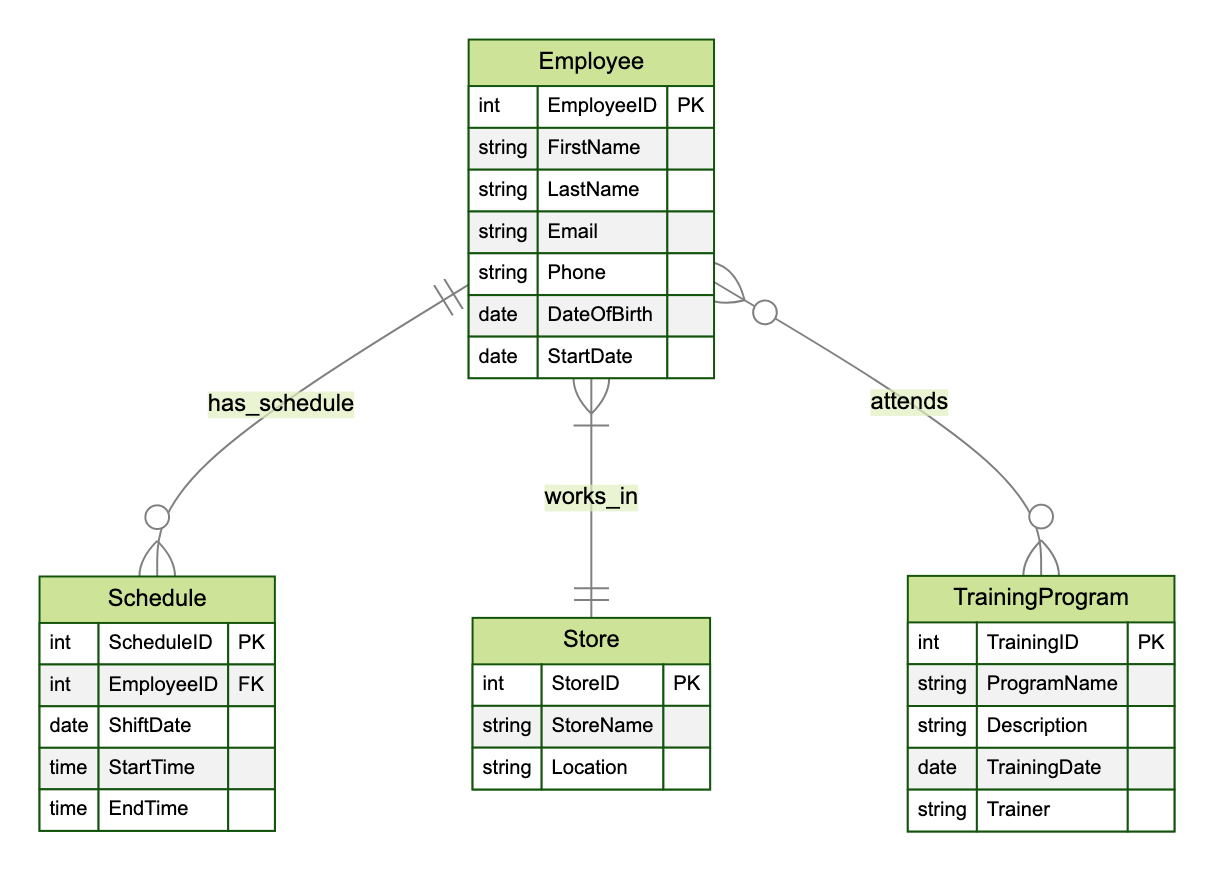What is the primary key of the Employee entity? The primary key of the Employee entity is EmployeeID, which uniquely identifies each employee in the diagram.
Answer: EmployeeID How many attributes does the Store entity have? The Store entity has three attributes: StoreID, StoreName, and Location. This count comes from looking at the attributes listed under the Store entity in the diagram.
Answer: 3 What is the relationship type between Employee and TrainingProgram? The relationship type between Employee and TrainingProgram is many-to-many, as indicated by the connective notation that shows an employee can attend multiple training programs and each training program can be attended by multiple employees.
Answer: many-to-many Which attribute connects Schedule to Employee? The attribute that connects Schedule to Employee is EmployeeID. This is a foreign key in the Schedule entity that refers to the EmployeeID in the Employee entity, establishing the relationship.
Answer: EmployeeID How many entities are present in this diagram? There are four entities present in this diagram: Employee, Store, Schedule, and TrainingProgram. This count is obtained by counting the entities listed in the diagram description.
Answer: 4 What are the attributes of the TrainingProgram entity? The attributes of the TrainingProgram entity are TrainingID, ProgramName, Description, TrainingDate, and Trainer. This information is directly taken from the attributes listed under the TrainingProgram entity in the diagram.
Answer: TrainingID, ProgramName, Description, TrainingDate, Trainer Which entity does the Schedule entity have a direct relationship with? The Schedule entity has a direct relationship with Employee, as it has a relationship denoting that a schedule is assigned to an employee.
Answer: Employee What can be said about the relationship between Store and Employee? The relationship between Store and Employee is one-to-many, indicated by the relationship notation that shows a store can have multiple employees working in it, but each employee works in only one store.
Answer: one-to-many 